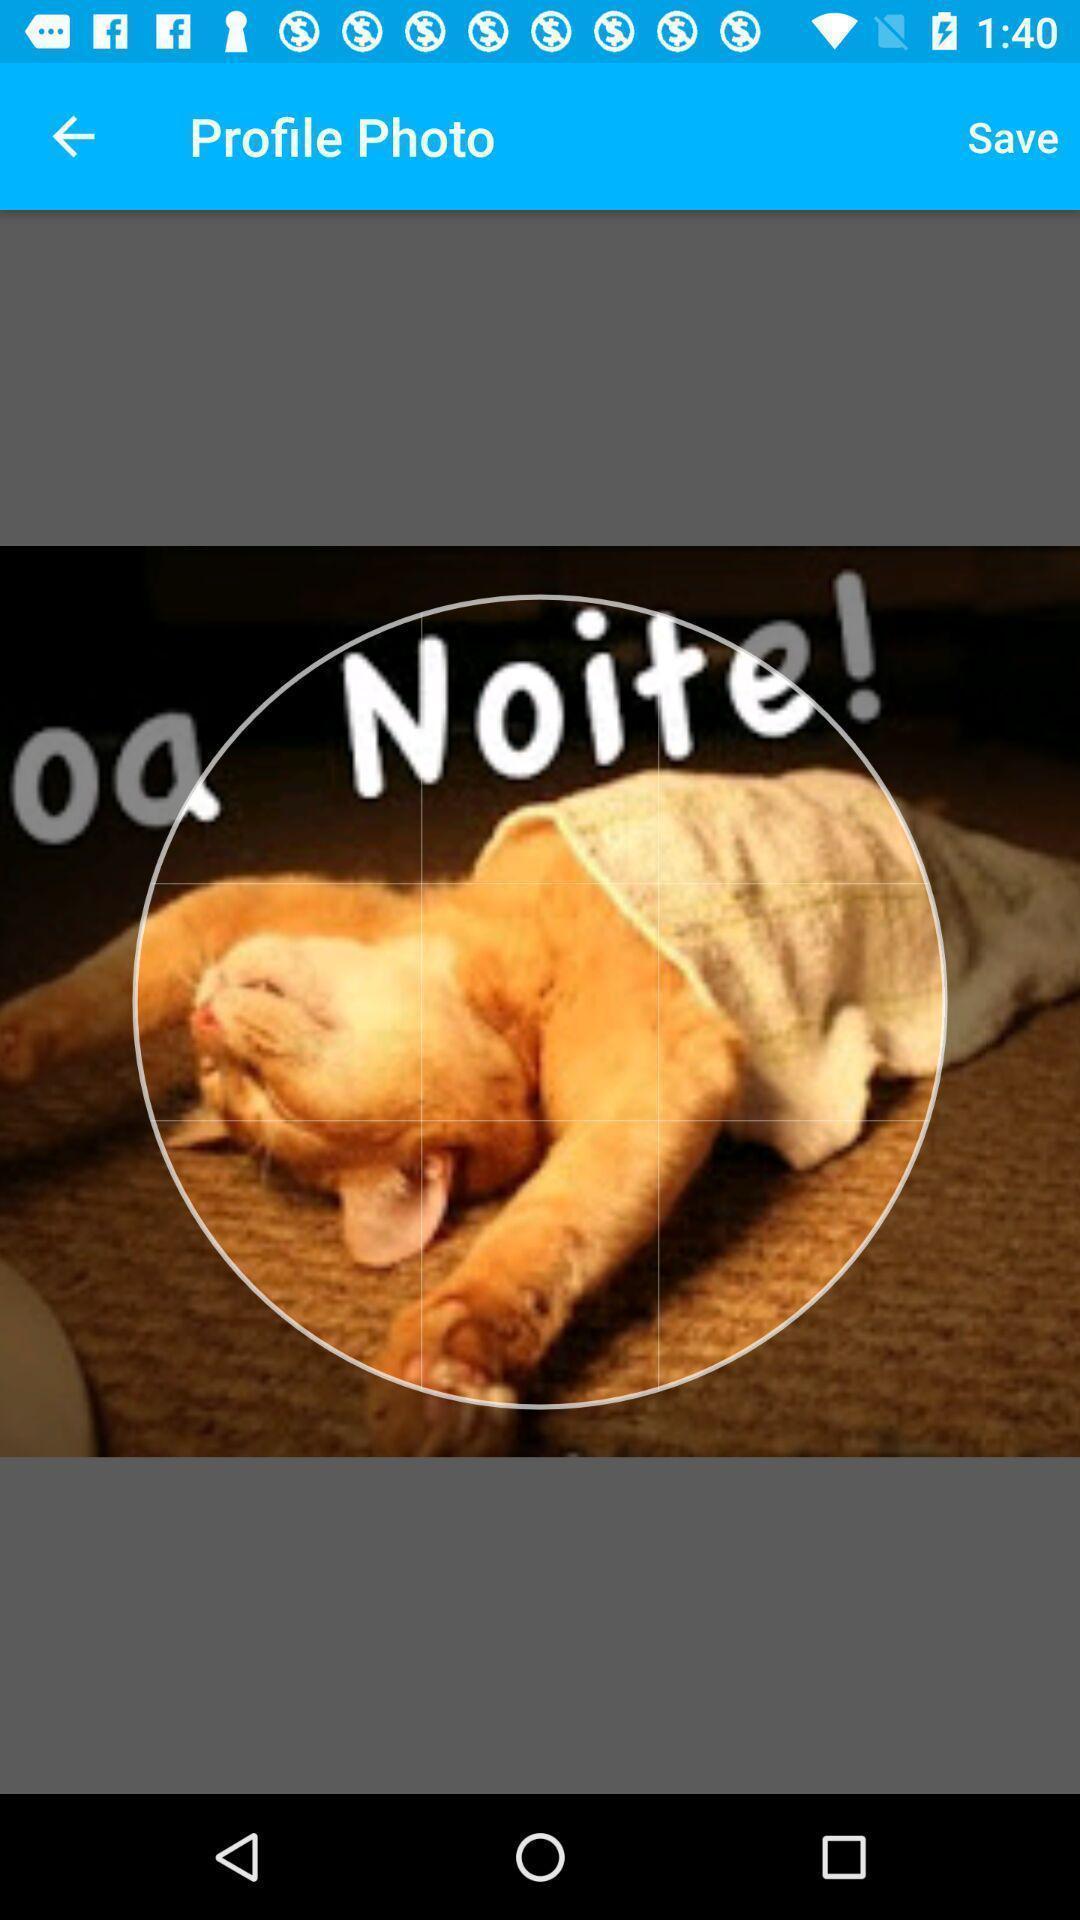Explain the elements present in this screenshot. Page showing about profile photo to select. 